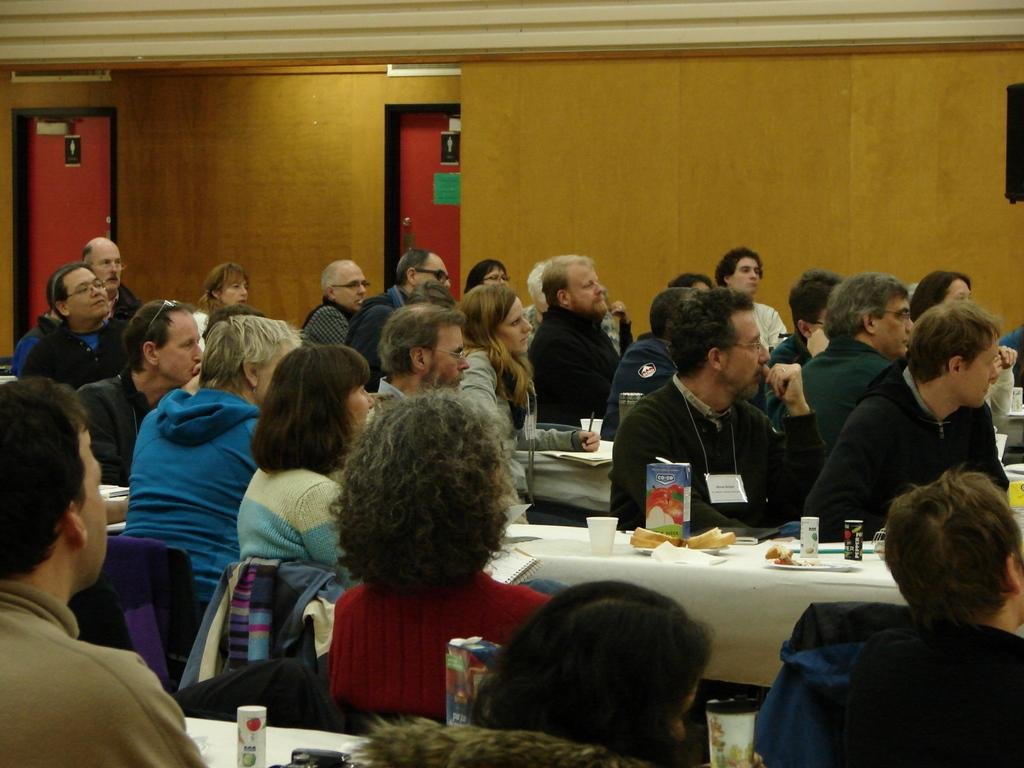How many people are in the image? There is a group of people in the image. What are the people doing in the image? The people are sitting on chairs. What can be seen in the background of the image? There is a wall in the image. What objects are on the tables in the image? There are plates, glasses, and books on the tables. What type of plastic is being used to whip the books in the image? There is no plastic or whipping of books present in the image. 